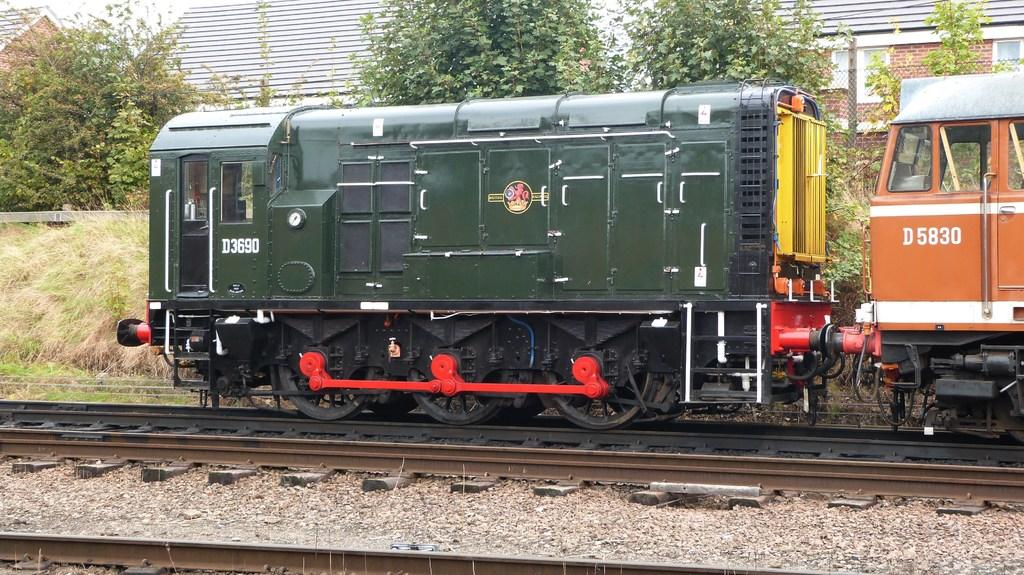Provide a one-sentence caption for the provided image. A green locomotive with D3690 as the numbers goes down the tracks. 